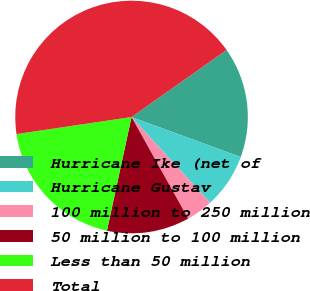Convert chart. <chart><loc_0><loc_0><loc_500><loc_500><pie_chart><fcel>Hurricane Ike (net of<fcel>Hurricane Gustav<fcel>100 million to 250 million<fcel>50 million to 100 million<fcel>Less than 50 million<fcel>Total<nl><fcel>15.37%<fcel>7.6%<fcel>3.71%<fcel>11.49%<fcel>19.26%<fcel>42.57%<nl></chart> 